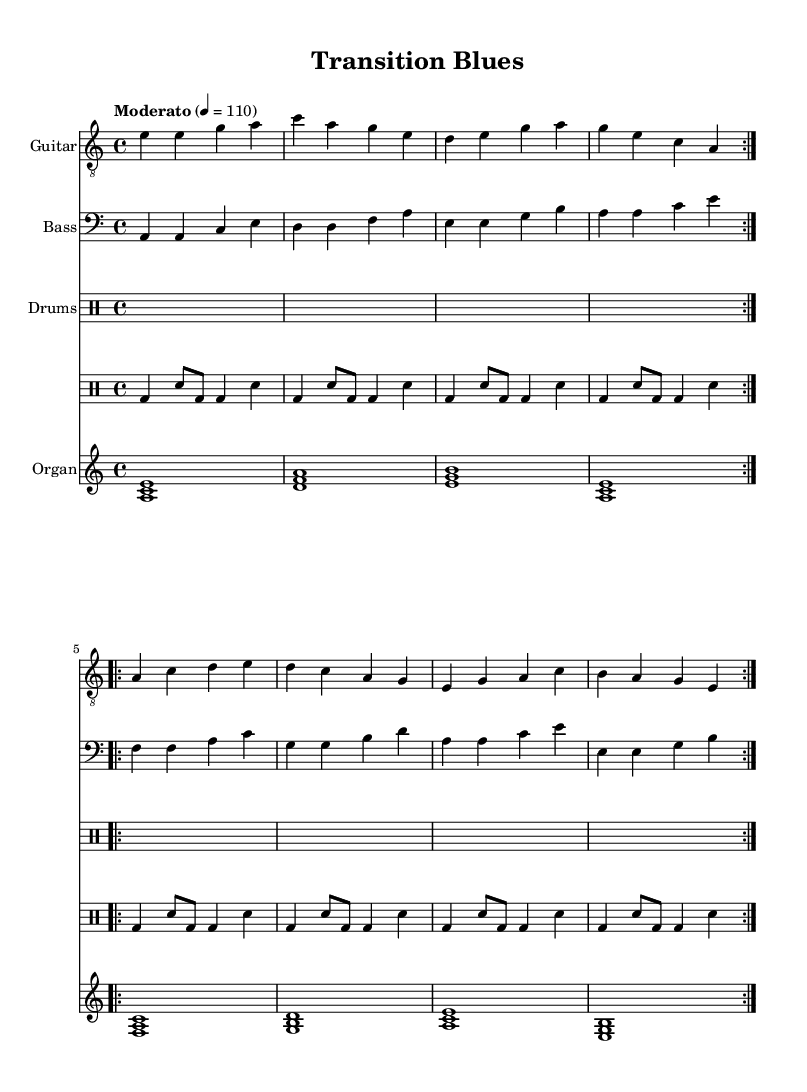What is the key signature of this music? The key signature is A minor, which has no sharps or flats. A minor is the relative key of C major, and it can be identified by looking at the absence of any sharps or flats in the signature.
Answer: A minor What is the time signature of this music? The time signature is 4/4, which means there are four beats in a measure and the quarter note gets one beat. This can be determined from the time signature indication at the beginning of the score.
Answer: 4/4 What is the tempo marking for this piece? The tempo marking is "Moderato," indicating a moderate pace of 110 beats per minute. The tempo is usually specified above the staff and includes the beats per minute as numerical value.
Answer: Moderato How many times does the guitar section repeat? The guitar section repeats four times in total: two sections of four measures each are repeated. This can be observed by the repeat signs in the notation, indicating the sections to be played again.
Answer: Four times What is the first chord played by the organ? The first chord played by the organ is A minor. This can be identified by looking at the notes played in the first measure of the organ music staff. The chord is formed by the notes A, C, and E, which together create an A minor triad.
Answer: A minor How many instruments are used in this composition? There are four instruments used: Guitar, Bass, Drums, and Organ. This is evident from the separate staff sections labeled for each instrument in the score, showing their unique contributions to the music.
Answer: Four instruments What musical genre does this piece represent? The piece represents the Electric Blues genre, specifically blending blues and rock elements to reflect socio-economic themes. This can be inferred from the rhythmic structure, instrumentation, and overall style typical of blues-rock music.
Answer: Electric Blues 